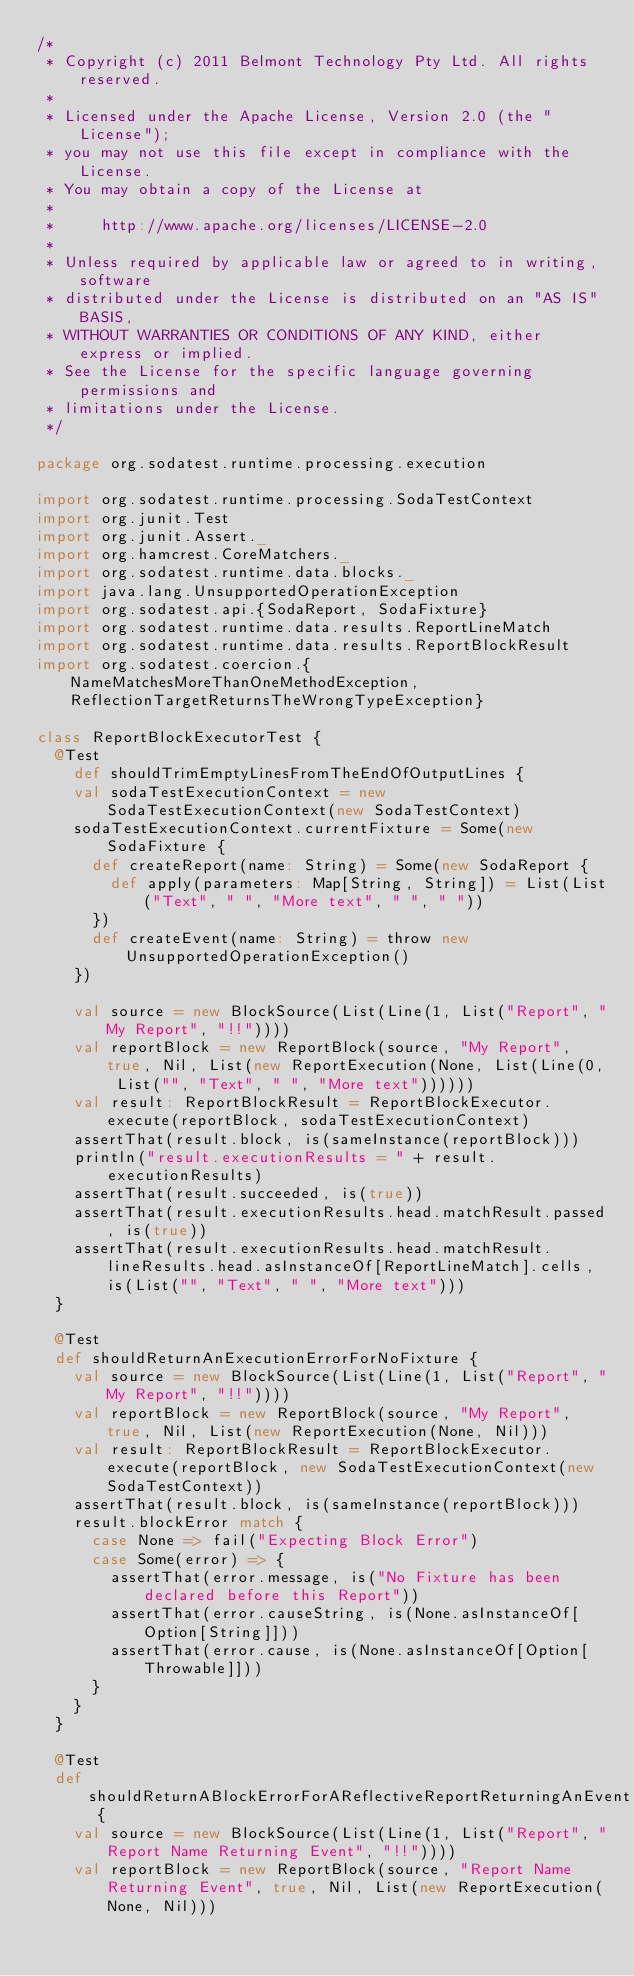<code> <loc_0><loc_0><loc_500><loc_500><_Scala_>/*
 * Copyright (c) 2011 Belmont Technology Pty Ltd. All rights reserved.
 *
 * Licensed under the Apache License, Version 2.0 (the "License");
 * you may not use this file except in compliance with the License.
 * You may obtain a copy of the License at
 *
 *     http://www.apache.org/licenses/LICENSE-2.0
 *
 * Unless required by applicable law or agreed to in writing, software
 * distributed under the License is distributed on an "AS IS" BASIS,
 * WITHOUT WARRANTIES OR CONDITIONS OF ANY KIND, either express or implied.
 * See the License for the specific language governing permissions and
 * limitations under the License.
 */

package org.sodatest.runtime.processing.execution

import org.sodatest.runtime.processing.SodaTestContext
import org.junit.Test
import org.junit.Assert._
import org.hamcrest.CoreMatchers._
import org.sodatest.runtime.data.blocks._
import java.lang.UnsupportedOperationException
import org.sodatest.api.{SodaReport, SodaFixture}
import org.sodatest.runtime.data.results.ReportLineMatch
import org.sodatest.runtime.data.results.ReportBlockResult
import org.sodatest.coercion.{NameMatchesMoreThanOneMethodException, ReflectionTargetReturnsTheWrongTypeException}

class ReportBlockExecutorTest {
  @Test
    def shouldTrimEmptyLinesFromTheEndOfOutputLines {
    val sodaTestExecutionContext = new SodaTestExecutionContext(new SodaTestContext)
    sodaTestExecutionContext.currentFixture = Some(new SodaFixture {
      def createReport(name: String) = Some(new SodaReport {
        def apply(parameters: Map[String, String]) = List(List("Text", " ", "More text", " ", " "))
      })
      def createEvent(name: String) = throw new UnsupportedOperationException()
    })

    val source = new BlockSource(List(Line(1, List("Report", "My Report", "!!"))))
    val reportBlock = new ReportBlock(source, "My Report", true, Nil, List(new ReportExecution(None, List(Line(0, List("", "Text", " ", "More text"))))))
    val result: ReportBlockResult = ReportBlockExecutor.execute(reportBlock, sodaTestExecutionContext)
    assertThat(result.block, is(sameInstance(reportBlock)))
    println("result.executionResults = " + result.executionResults)
    assertThat(result.succeeded, is(true))
    assertThat(result.executionResults.head.matchResult.passed, is(true))
    assertThat(result.executionResults.head.matchResult.lineResults.head.asInstanceOf[ReportLineMatch].cells, is(List("", "Text", " ", "More text")))
  }

  @Test
  def shouldReturnAnExecutionErrorForNoFixture {
    val source = new BlockSource(List(Line(1, List("Report", "My Report", "!!"))))
    val reportBlock = new ReportBlock(source, "My Report", true, Nil, List(new ReportExecution(None, Nil)))
    val result: ReportBlockResult = ReportBlockExecutor.execute(reportBlock, new SodaTestExecutionContext(new SodaTestContext))
    assertThat(result.block, is(sameInstance(reportBlock)))
    result.blockError match {
      case None => fail("Expecting Block Error")
      case Some(error) => {
        assertThat(error.message, is("No Fixture has been declared before this Report"))
        assertThat(error.causeString, is(None.asInstanceOf[Option[String]]))
        assertThat(error.cause, is(None.asInstanceOf[Option[Throwable]]))
      }
    }
  }

  @Test
  def shouldReturnABlockErrorForAReflectiveReportReturningAnEvent {
    val source = new BlockSource(List(Line(1, List("Report", "Report Name Returning Event", "!!"))))
    val reportBlock = new ReportBlock(source, "Report Name Returning Event", true, Nil, List(new ReportExecution(None, Nil)))</code> 